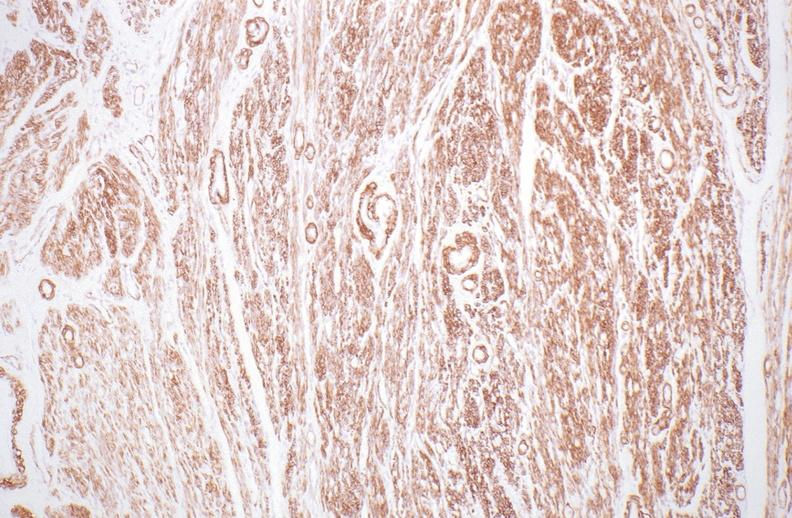what does this image show?
Answer the question using a single word or phrase. Normal uterus 